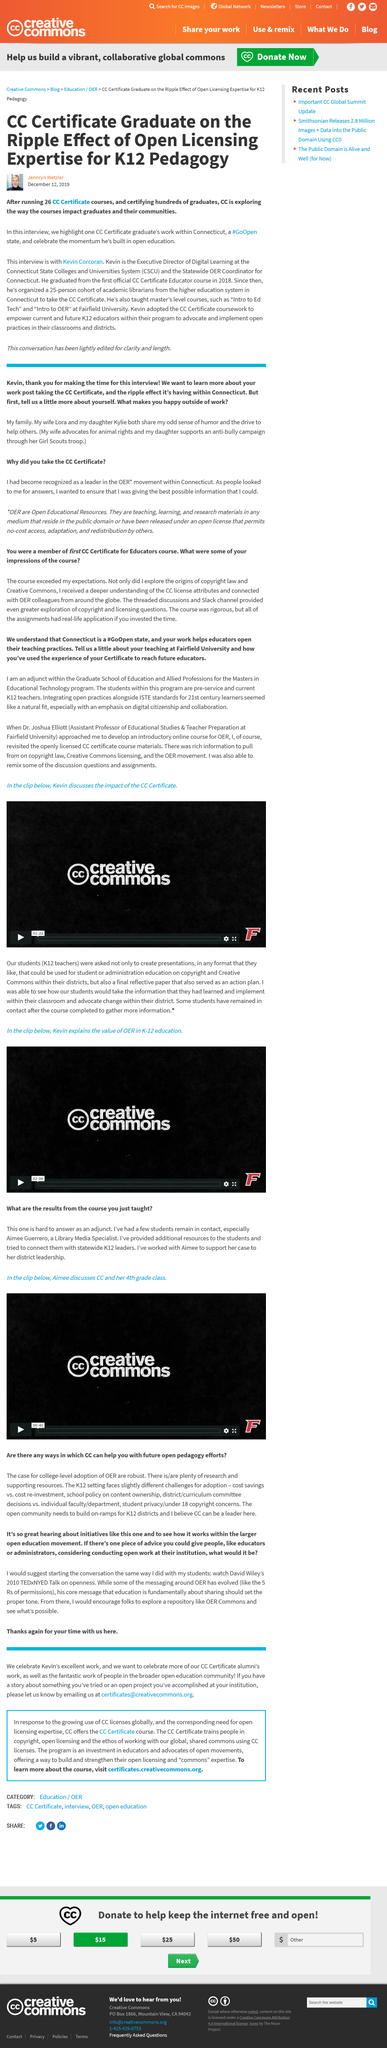Highlight a few significant elements in this photo. CC has run a total of 26 CC certificate courses. The interview was conducted with Kevin Corcoran, the director of digital learning at the Connecticut state college and university system. On December 12th, 2019, Jennryn Wetzler published this article. 